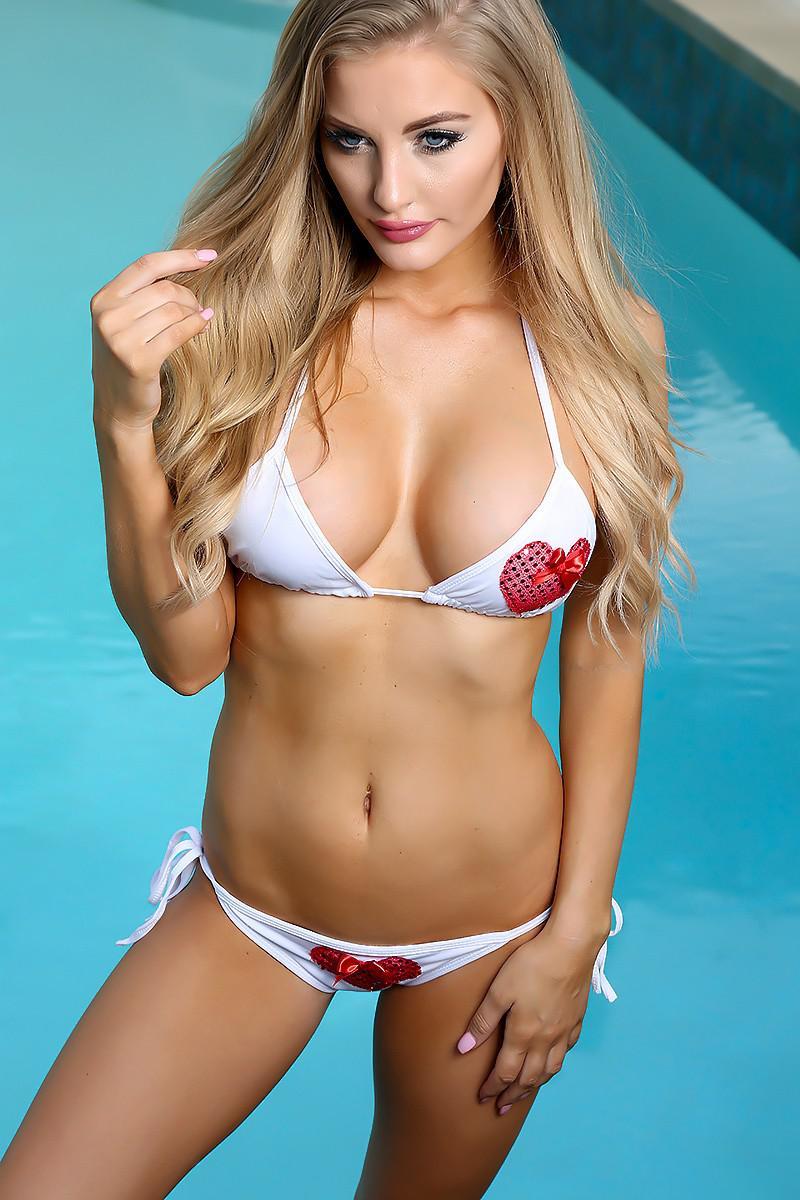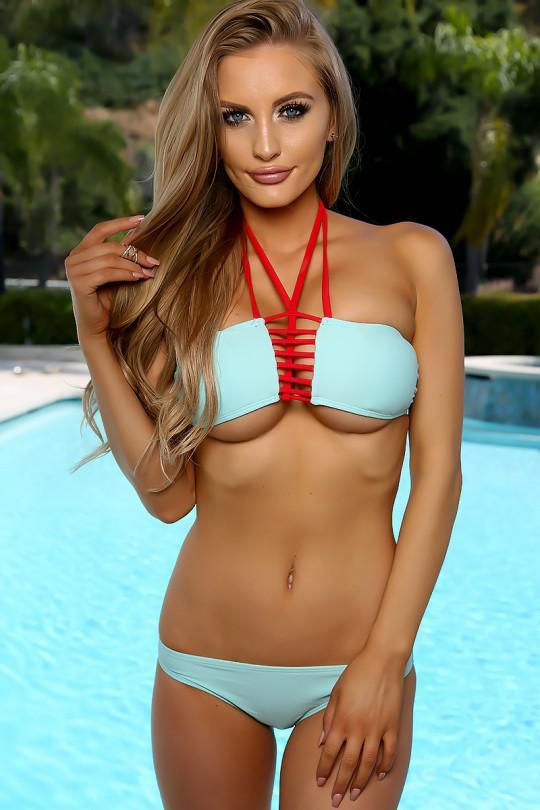The first image is the image on the left, the second image is the image on the right. Considering the images on both sides, is "The bikini in the image on the left is tied at the hip" valid? Answer yes or no. Yes. 